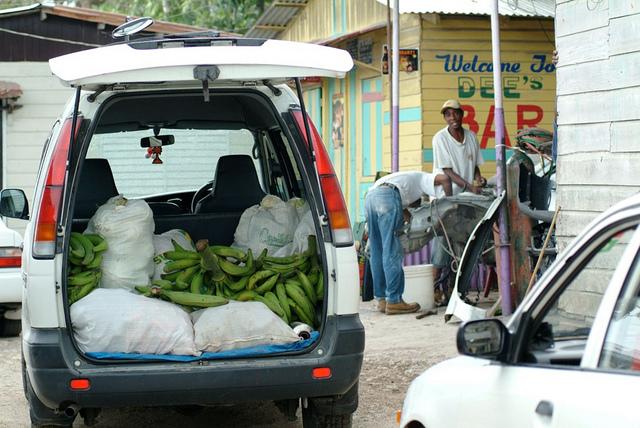What kind of fruits are pictured in the back of the car?
Short answer required. Bananas. Are the fruits ripe?
Be succinct. No. Is the trunk open?
Concise answer only. Yes. Is there a tree in this image?
Quick response, please. No. 